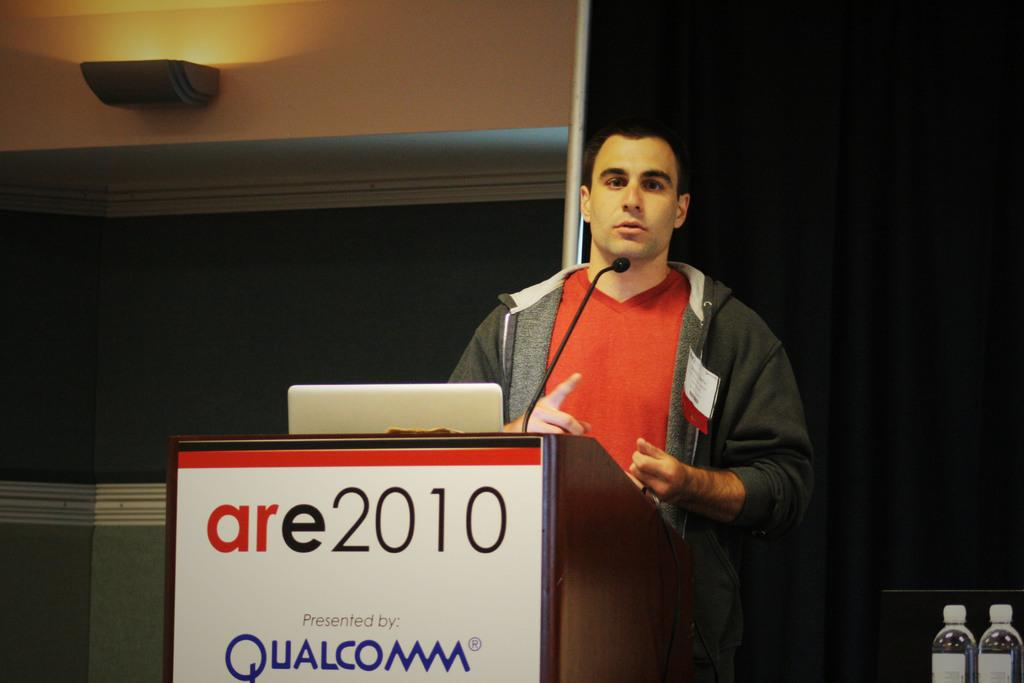What is the man in the image doing? There is a man standing in the image, but we cannot determine his exact activity from the given facts. What object is present for amplifying sound in the image? There is a microphone in the image. What is the man possibly using for his presentation in the image? There is a laptop in the image, which the man might be using for his presentation. What object is present for the man to rest his notes or materials on in the image? There is a podium in the image. What items can be seen on the right side of the image? There are two bottles on the right side of the image. What is the source of light in the image? There is a light on the top of the image. How many knives are visible in the image? There are no knives present in the image. What type of joke is the man telling in the image? There is no indication in the image that the man is telling a joke, and we cannot determine his exact activity from the given facts. 